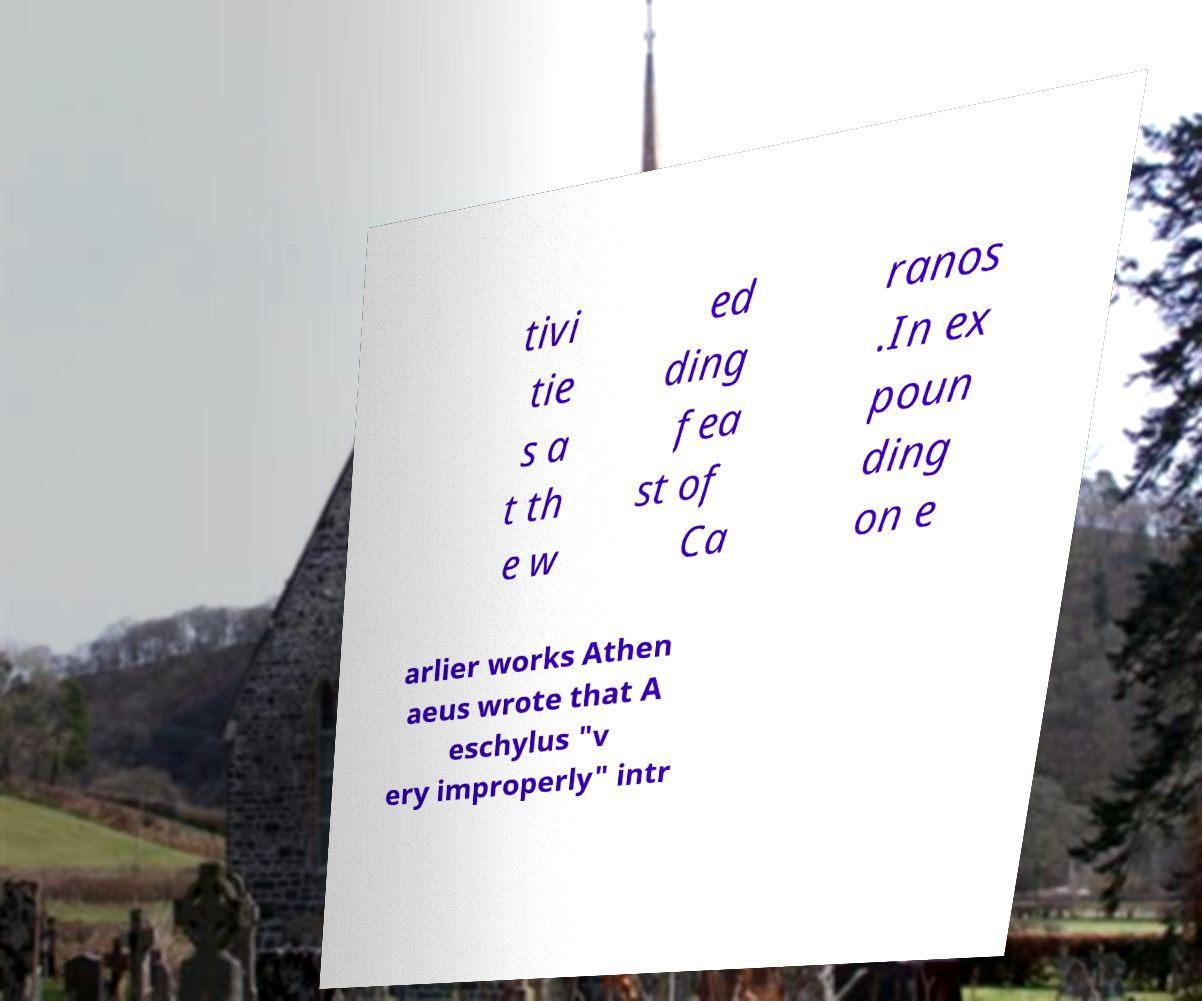I need the written content from this picture converted into text. Can you do that? tivi tie s a t th e w ed ding fea st of Ca ranos .In ex poun ding on e arlier works Athen aeus wrote that A eschylus "v ery improperly" intr 